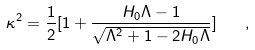Convert formula to latex. <formula><loc_0><loc_0><loc_500><loc_500>\kappa ^ { 2 } = \frac { 1 } { 2 } [ 1 + \frac { H _ { 0 } \Lambda - 1 } { \sqrt { \Lambda ^ { 2 } + 1 - 2 H _ { 0 } \Lambda } } ] \quad ,</formula> 